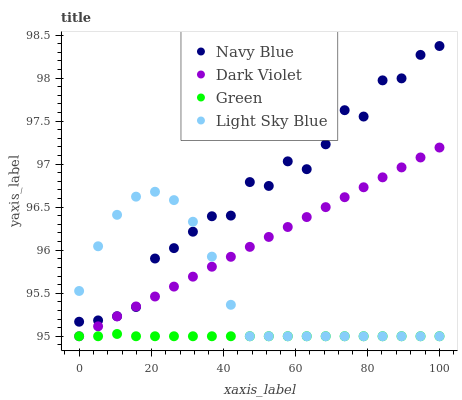Does Green have the minimum area under the curve?
Answer yes or no. Yes. Does Navy Blue have the maximum area under the curve?
Answer yes or no. Yes. Does Light Sky Blue have the minimum area under the curve?
Answer yes or no. No. Does Light Sky Blue have the maximum area under the curve?
Answer yes or no. No. Is Dark Violet the smoothest?
Answer yes or no. Yes. Is Navy Blue the roughest?
Answer yes or no. Yes. Is Light Sky Blue the smoothest?
Answer yes or no. No. Is Light Sky Blue the roughest?
Answer yes or no. No. Does Light Sky Blue have the lowest value?
Answer yes or no. Yes. Does Navy Blue have the highest value?
Answer yes or no. Yes. Does Light Sky Blue have the highest value?
Answer yes or no. No. Is Green less than Navy Blue?
Answer yes or no. Yes. Is Navy Blue greater than Green?
Answer yes or no. Yes. Does Green intersect Dark Violet?
Answer yes or no. Yes. Is Green less than Dark Violet?
Answer yes or no. No. Is Green greater than Dark Violet?
Answer yes or no. No. Does Green intersect Navy Blue?
Answer yes or no. No. 